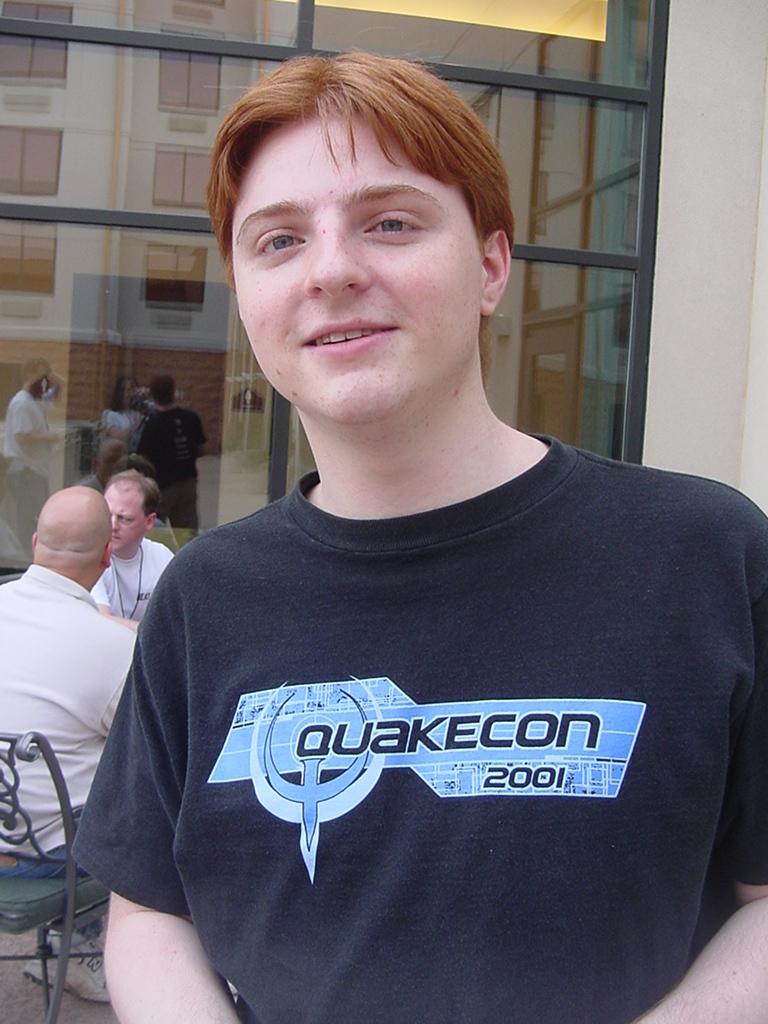Based on his shirt do you think this kid is a software geek?
Ensure brevity in your answer.  Yes. What year is on the shirt?
Provide a short and direct response. 2001. 